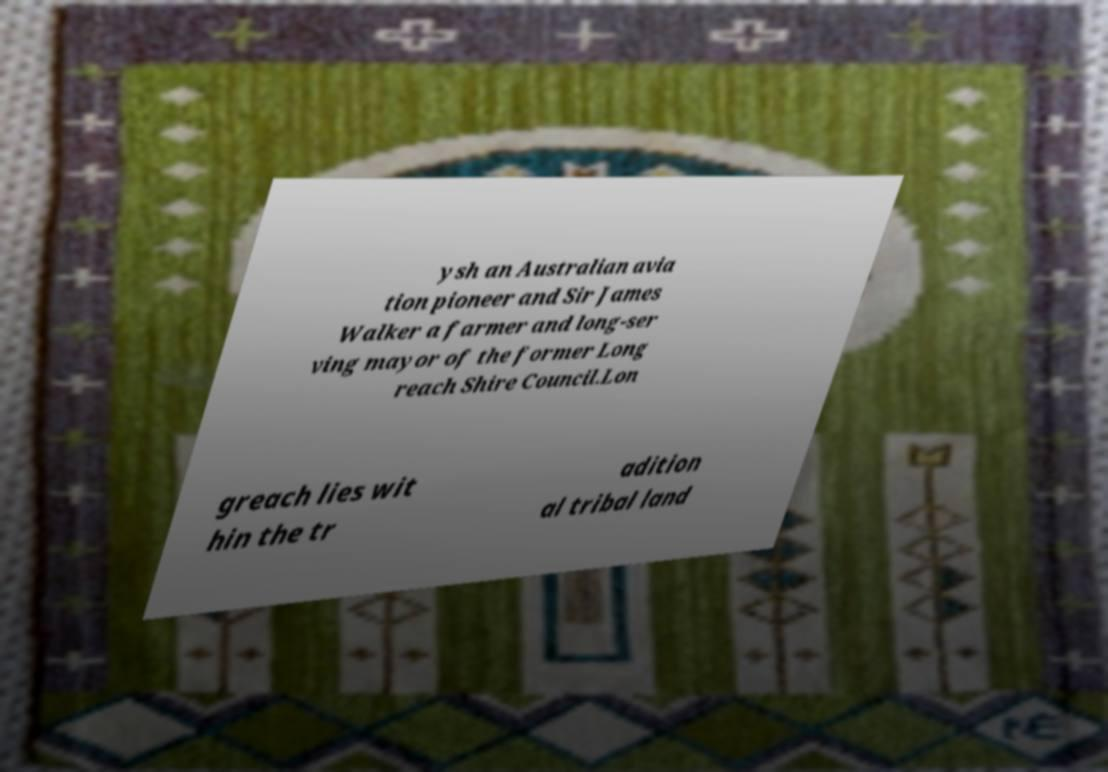What messages or text are displayed in this image? I need them in a readable, typed format. ysh an Australian avia tion pioneer and Sir James Walker a farmer and long-ser ving mayor of the former Long reach Shire Council.Lon greach lies wit hin the tr adition al tribal land 